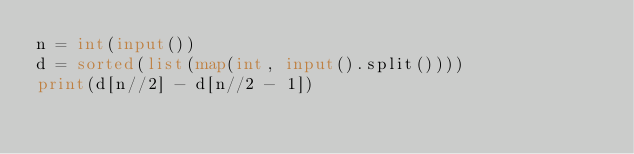<code> <loc_0><loc_0><loc_500><loc_500><_Python_>n = int(input())
d = sorted(list(map(int, input().split())))
print(d[n//2] - d[n//2 - 1])</code> 